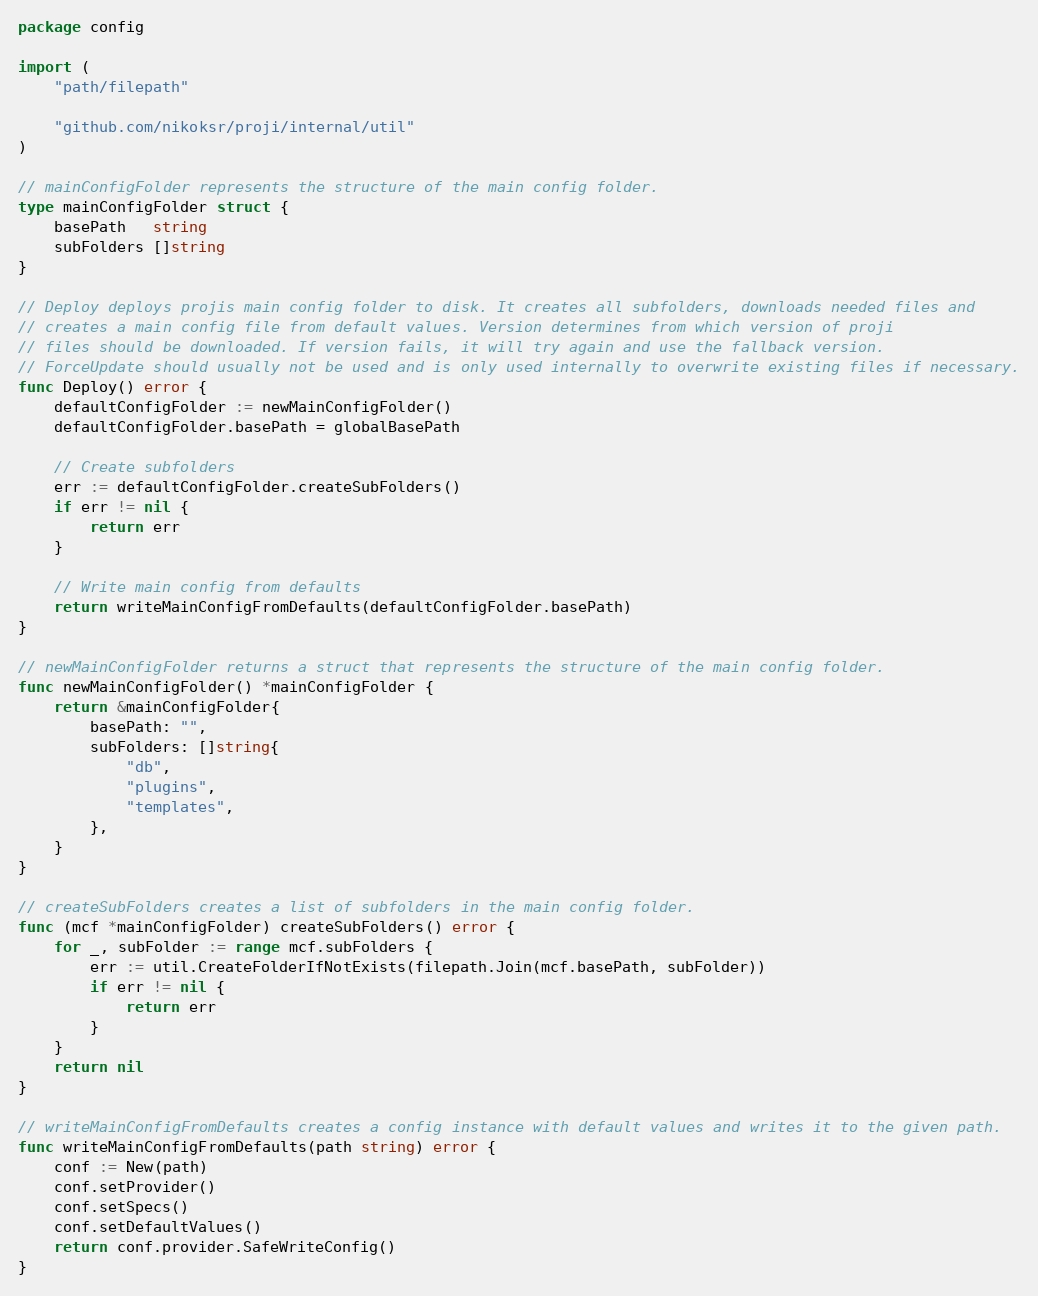<code> <loc_0><loc_0><loc_500><loc_500><_Go_>package config

import (
	"path/filepath"

	"github.com/nikoksr/proji/internal/util"
)

// mainConfigFolder represents the structure of the main config folder.
type mainConfigFolder struct {
	basePath   string
	subFolders []string
}

// Deploy deploys projis main config folder to disk. It creates all subfolders, downloads needed files and
// creates a main config file from default values. Version determines from which version of proji
// files should be downloaded. If version fails, it will try again and use the fallback version.
// ForceUpdate should usually not be used and is only used internally to overwrite existing files if necessary.
func Deploy() error {
	defaultConfigFolder := newMainConfigFolder()
	defaultConfigFolder.basePath = globalBasePath

	// Create subfolders
	err := defaultConfigFolder.createSubFolders()
	if err != nil {
		return err
	}

	// Write main config from defaults
	return writeMainConfigFromDefaults(defaultConfigFolder.basePath)
}

// newMainConfigFolder returns a struct that represents the structure of the main config folder.
func newMainConfigFolder() *mainConfigFolder {
	return &mainConfigFolder{
		basePath: "",
		subFolders: []string{
			"db",
			"plugins",
			"templates",
		},
	}
}

// createSubFolders creates a list of subfolders in the main config folder.
func (mcf *mainConfigFolder) createSubFolders() error {
	for _, subFolder := range mcf.subFolders {
		err := util.CreateFolderIfNotExists(filepath.Join(mcf.basePath, subFolder))
		if err != nil {
			return err
		}
	}
	return nil
}

// writeMainConfigFromDefaults creates a config instance with default values and writes it to the given path.
func writeMainConfigFromDefaults(path string) error {
	conf := New(path)
	conf.setProvider()
	conf.setSpecs()
	conf.setDefaultValues()
	return conf.provider.SafeWriteConfig()
}
</code> 